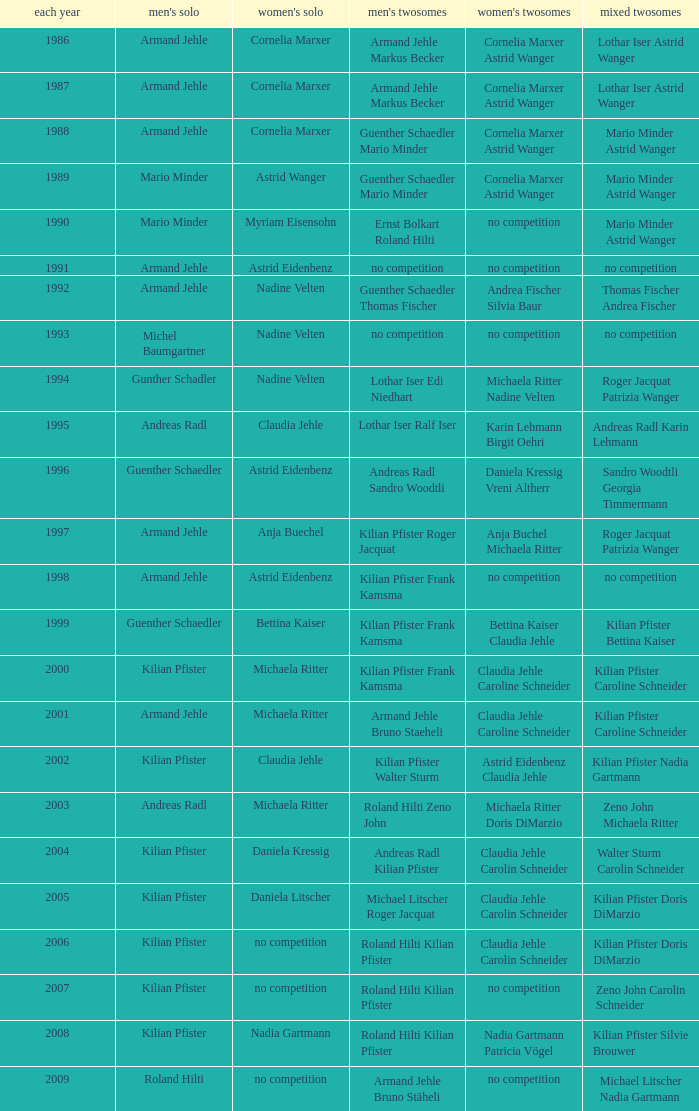In the year 2006, the womens singles had no competition and the mens doubles were roland hilti kilian pfister, what were the womens doubles Claudia Jehle Carolin Schneider. 